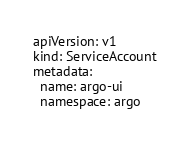Convert code to text. <code><loc_0><loc_0><loc_500><loc_500><_YAML_>apiVersion: v1
kind: ServiceAccount
metadata:
  name: argo-ui
  namespace: argo
</code> 